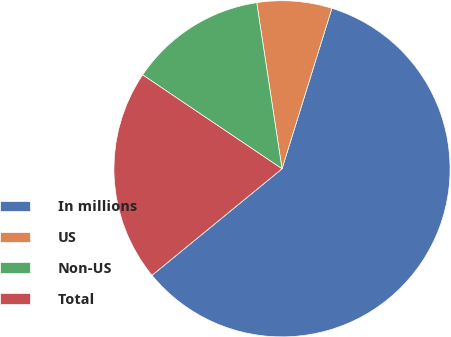<chart> <loc_0><loc_0><loc_500><loc_500><pie_chart><fcel>In millions<fcel>US<fcel>Non-US<fcel>Total<nl><fcel>59.28%<fcel>7.2%<fcel>13.16%<fcel>20.36%<nl></chart> 